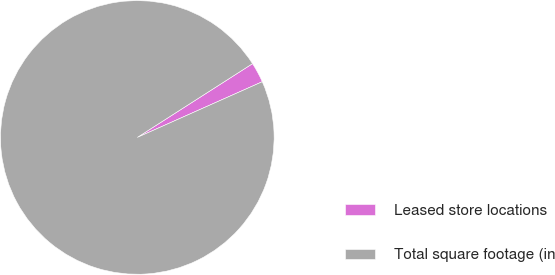Convert chart to OTSL. <chart><loc_0><loc_0><loc_500><loc_500><pie_chart><fcel>Leased store locations<fcel>Total square footage (in<nl><fcel>2.39%<fcel>97.61%<nl></chart> 